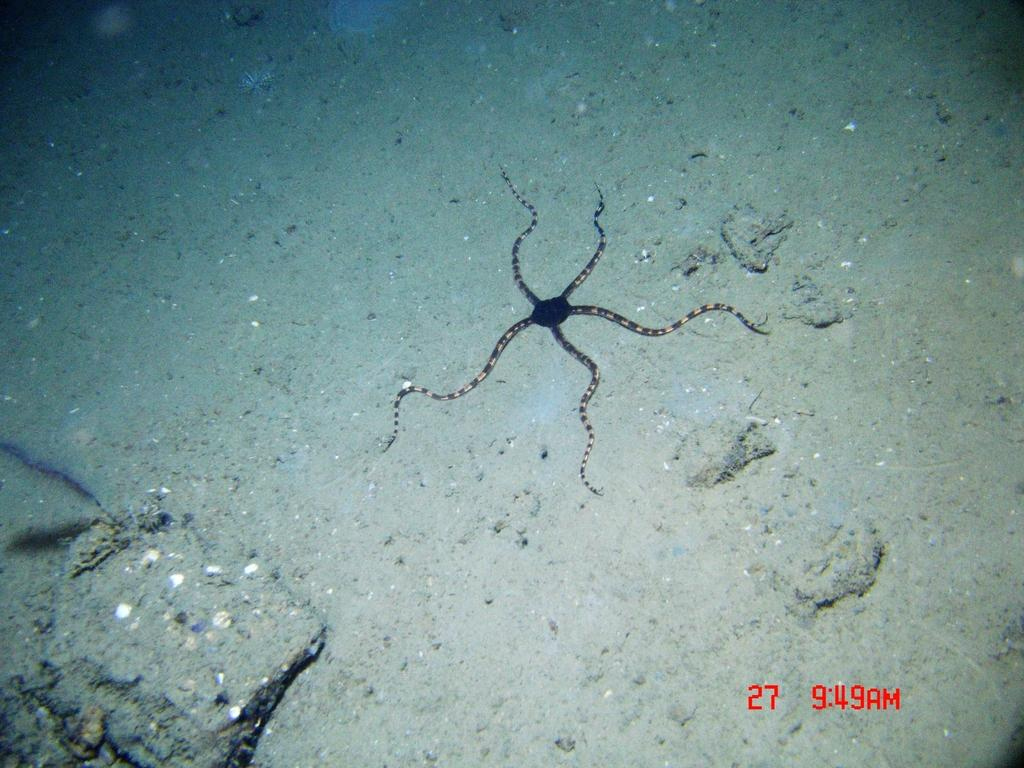What type of creature is in the image? There is a sea animal in the image. Where is the sea animal located? The sea animal is on the ground and in the water. What can be found near the sea animal? There are stones near the sea animal. What type of apples are hanging from the canvas in the image? There is no canvas or apples present in the image; it features a sea animal in the water with stones nearby. 